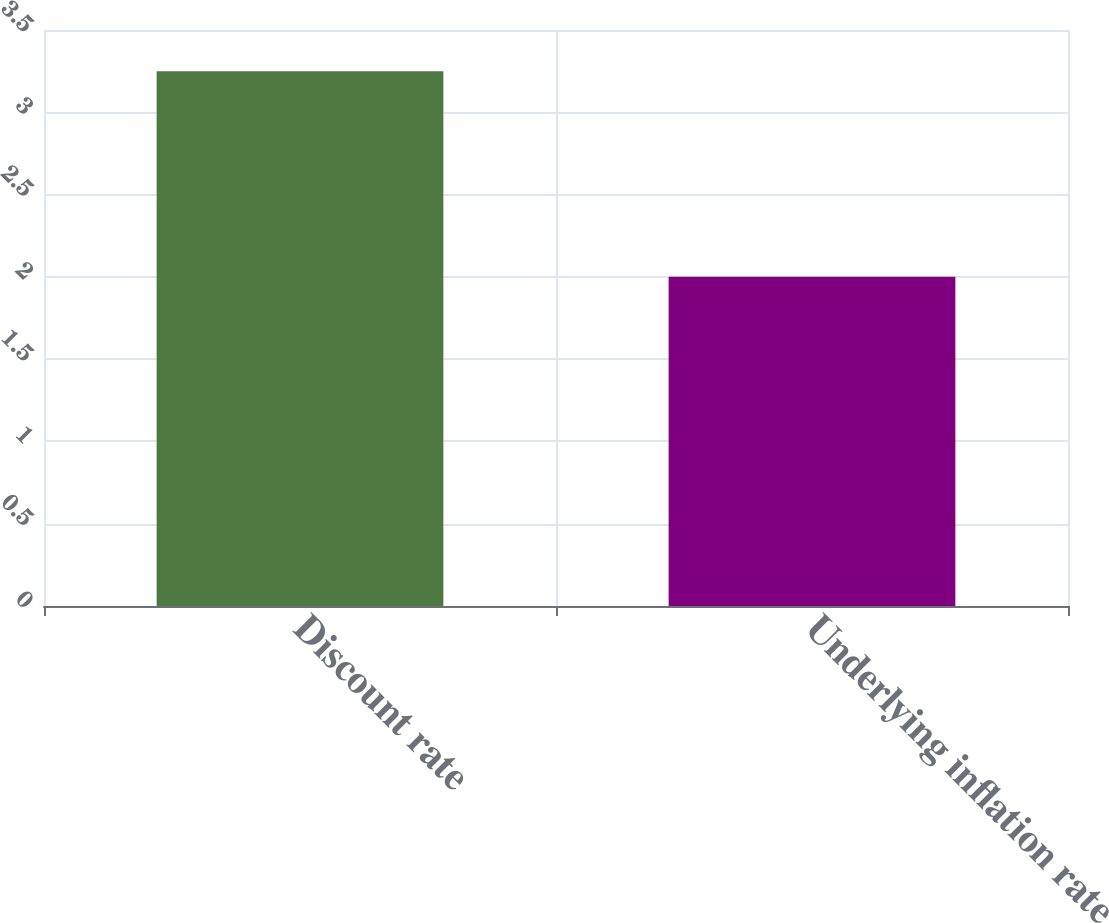Convert chart. <chart><loc_0><loc_0><loc_500><loc_500><bar_chart><fcel>Discount rate<fcel>Underlying inflation rate<nl><fcel>3.25<fcel>2<nl></chart> 